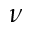Convert formula to latex. <formula><loc_0><loc_0><loc_500><loc_500>\nu</formula> 